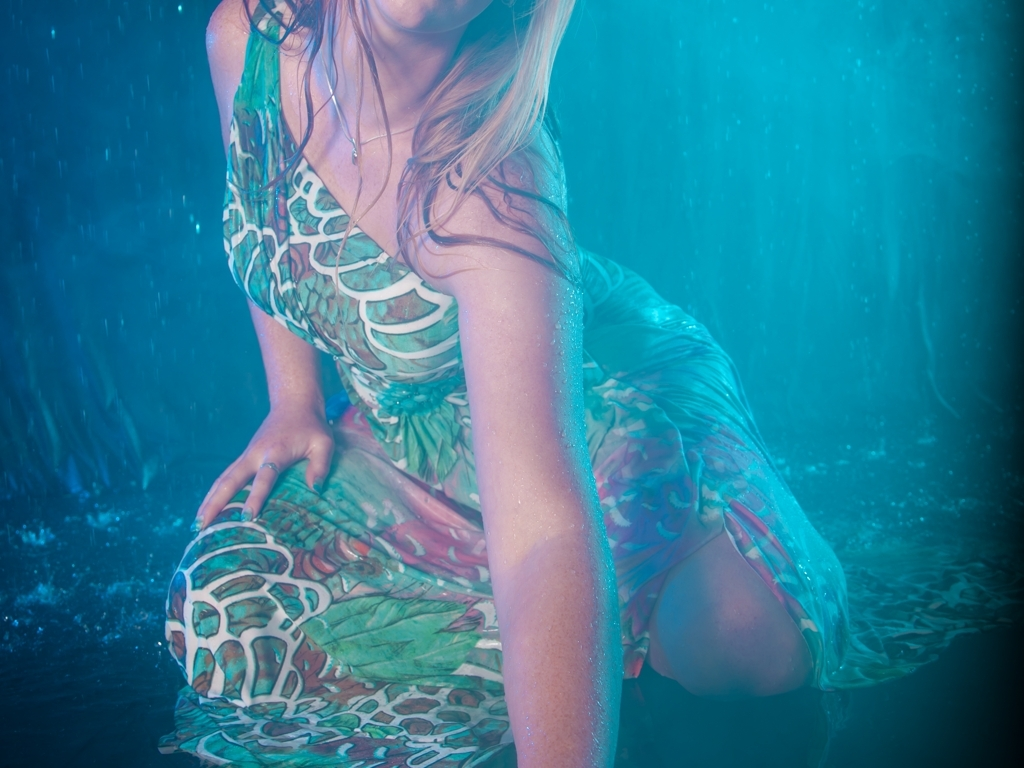Are the details of the person's hair, skin, and clothing texture clear? Yes, the image is of high quality, showcasing distinct details of the person's hair, skin, and clothing texture. The individual strands of the subject's hair are visible, skin tones are well-defined and natural, and the fabric of the clothing displays a clear pattern and texture, even under the influence of water which adds complexity to the perception of texture. 